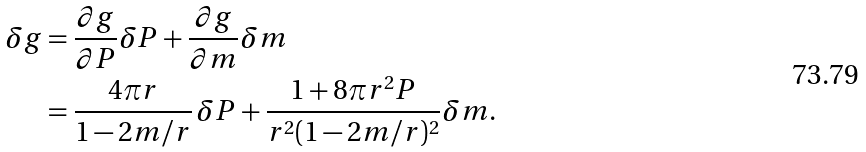Convert formula to latex. <formula><loc_0><loc_0><loc_500><loc_500>\delta g & = \frac { \partial g } { \partial P } \delta P + \frac { \partial g } { \partial m } \delta m \\ & = \frac { 4 \pi r } { 1 - 2 m / r } \, \delta P + \frac { 1 + 8 \pi r ^ { 2 } P } { r ^ { 2 } ( 1 - 2 m / r ) ^ { 2 } } \delta m .</formula> 